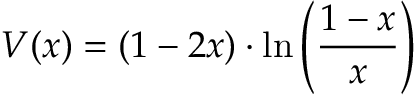<formula> <loc_0><loc_0><loc_500><loc_500>V ( x ) = ( 1 - 2 x ) \cdot \ln \left ( { \frac { 1 - x } { x } } \right )</formula> 